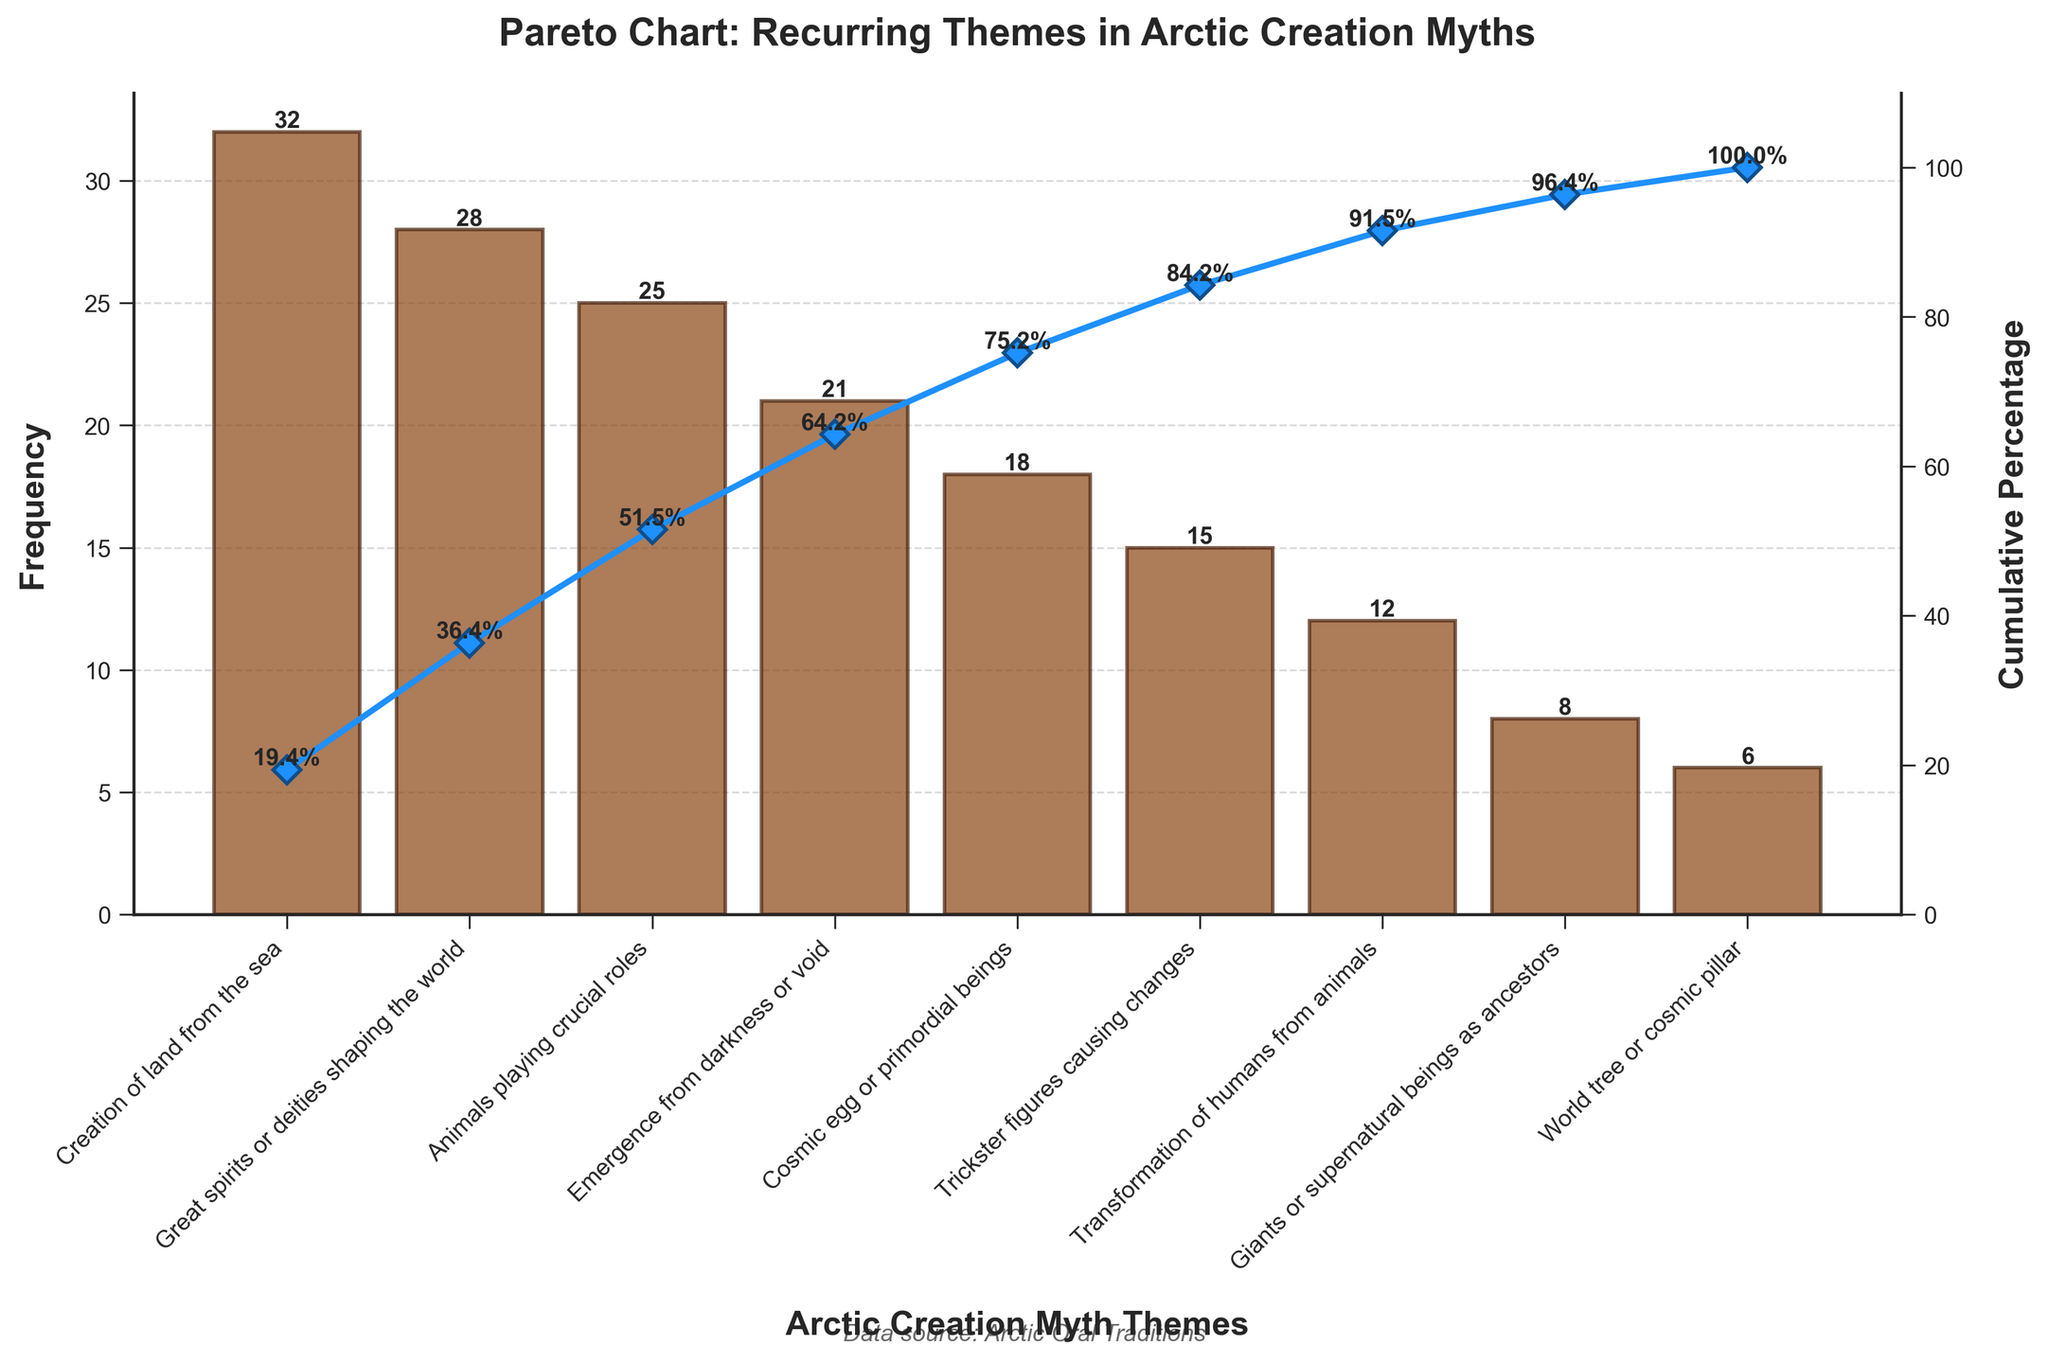What is the theme with the highest frequency in Arctic creation myths? The theme with the highest frequency can be identified by looking at the tallest bar in the bar plot. The tallest bar represents the "Creation of land from the sea" with a frequency of 32.
Answer: Creation of land from the sea What's the title of the figure? The title is found at the top of the figure. It reads "Pareto Chart: Recurring Themes in Arctic Creation Myths."
Answer: Pareto Chart: Recurring Themes in Arctic Creation Myths Which theme has a frequency of 15? To find the theme with a frequency of 15, locate the bar with a height of 15 in the bar chart. This represents the theme "Trickster figures causing changes."
Answer: Trickster figures causing changes Which theme appears least frequently in the myths? The theme that appears least frequently corresponds to the shortest bar in the bar chart. "World tree or cosmic pillar" with a frequency of 6 is the shortest.
Answer: World tree or cosmic pillar What is the cumulative percentage after the top three themes? To find this, look at the cumulative percentage line plot's value at the third position. This corresponds to the top three themes. The cumulative percentage is approximately 73.4% after the third theme (Animals playing crucial roles).
Answer: ~73.4% How many themes collectively account for 50% of all mentions in the myths? Calculate the cumulative percentages in order and find the number of themes needed to reach or surpass 50%. The first two themes "Creation of land from the sea" and "Great spirits or deities shaping the world" together achieve a cumulative percentage of 49.3%, and adding the third theme "Animals playing crucial roles" brings it to 73.4%. So, two themes almost reach it, a third takes it past 50%.
Answer: 3 Which theme has the closest cumulative percentage to 30%? Find the cumulative percentage closest to 30% in the cumulative percentage line plot. The cumulative percentage for the theme "Great spirits or deities shaping the world" is around 30.1%.
Answer: Great spirits or deities shaping the world What is the difference in frequency between the most common and least common themes? Subtract the frequency of the least common theme from the frequency of the most common theme. The most common theme has a frequency of 32, and the least common one has 6. 32 - 6 = 26.
Answer: 26 How many themes have a frequency greater than 20? Count the bars whose heights (frequencies) are greater than 20. The themes "Creation of land from the sea," "Great spirits or deities shaping the world," "Animals playing crucial roles," and "Emergence from darkness or void" have frequencies greater than 20.
Answer: 4 What is the combined frequency of "Cosmic egg or primordial beings" and "Transformation of humans from animals"? Add the frequencies of the two themes: 18 (Cosmic egg or primordial beings) + 12 (Transformation of humans from animals) = 30.
Answer: 30 